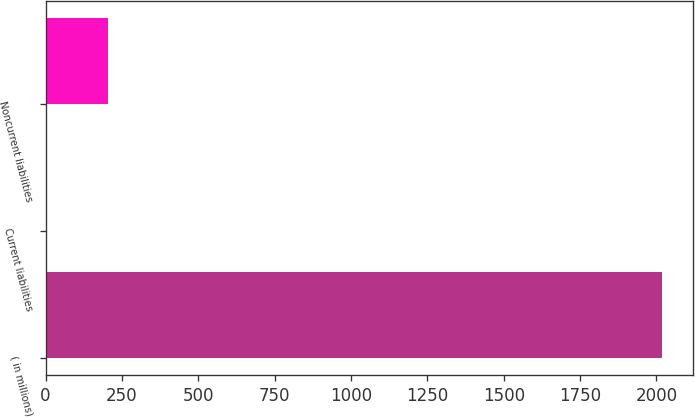<chart> <loc_0><loc_0><loc_500><loc_500><bar_chart><fcel>( in millions)<fcel>Current liabilities<fcel>Noncurrent liabilities<nl><fcel>2018<fcel>1.6<fcel>203.24<nl></chart> 